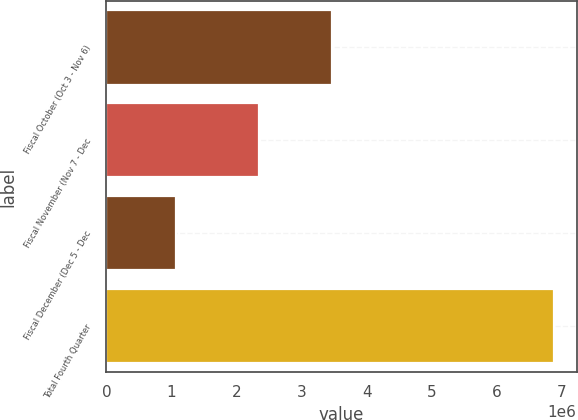Convert chart. <chart><loc_0><loc_0><loc_500><loc_500><bar_chart><fcel>Fiscal October (Oct 3 - Nov 6)<fcel>Fiscal November (Nov 7 - Dec<fcel>Fiscal December (Dec 5 - Dec<fcel>Total Fourth Quarter<nl><fcel>3.4701e+06<fcel>2.34282e+06<fcel>1.07214e+06<fcel>6.88506e+06<nl></chart> 